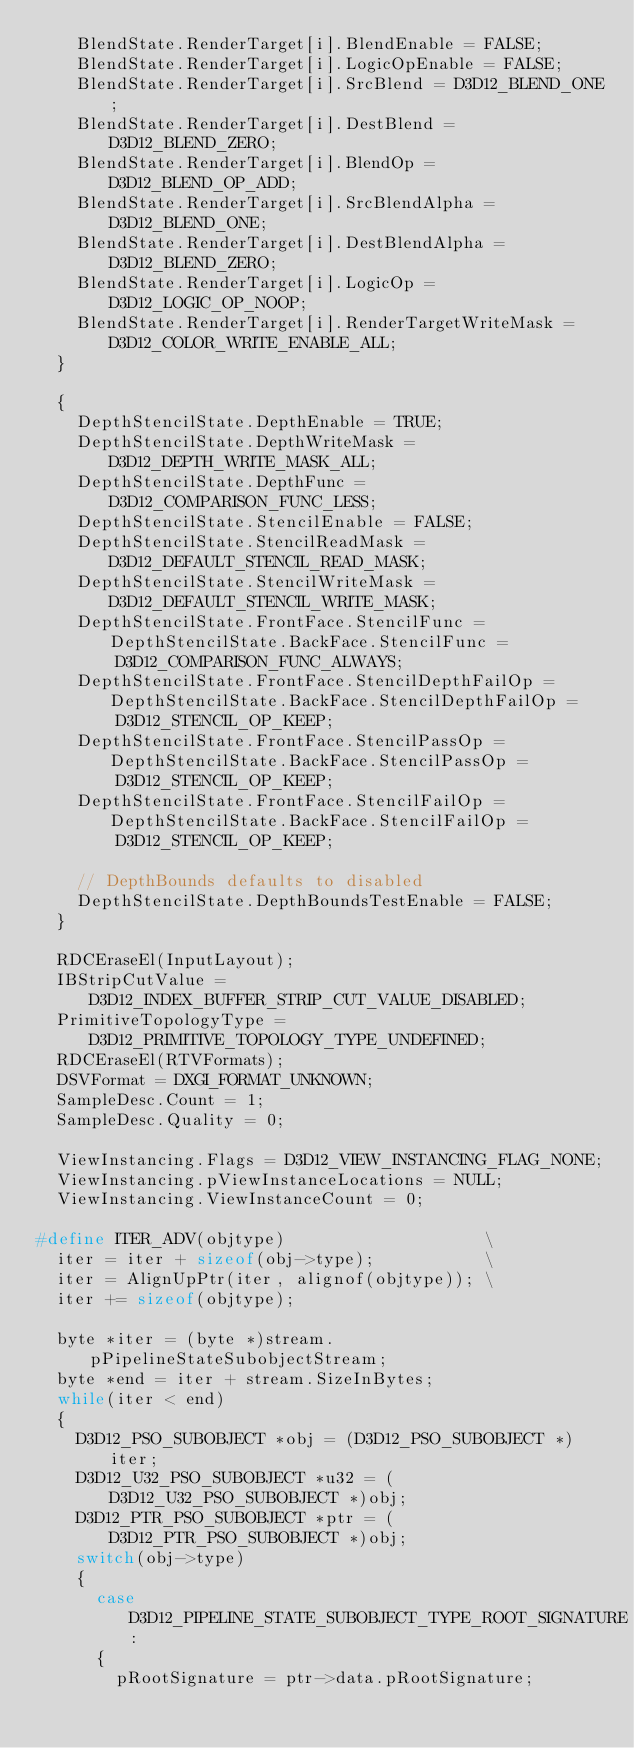<code> <loc_0><loc_0><loc_500><loc_500><_C++_>    BlendState.RenderTarget[i].BlendEnable = FALSE;
    BlendState.RenderTarget[i].LogicOpEnable = FALSE;
    BlendState.RenderTarget[i].SrcBlend = D3D12_BLEND_ONE;
    BlendState.RenderTarget[i].DestBlend = D3D12_BLEND_ZERO;
    BlendState.RenderTarget[i].BlendOp = D3D12_BLEND_OP_ADD;
    BlendState.RenderTarget[i].SrcBlendAlpha = D3D12_BLEND_ONE;
    BlendState.RenderTarget[i].DestBlendAlpha = D3D12_BLEND_ZERO;
    BlendState.RenderTarget[i].LogicOp = D3D12_LOGIC_OP_NOOP;
    BlendState.RenderTarget[i].RenderTargetWriteMask = D3D12_COLOR_WRITE_ENABLE_ALL;
  }

  {
    DepthStencilState.DepthEnable = TRUE;
    DepthStencilState.DepthWriteMask = D3D12_DEPTH_WRITE_MASK_ALL;
    DepthStencilState.DepthFunc = D3D12_COMPARISON_FUNC_LESS;
    DepthStencilState.StencilEnable = FALSE;
    DepthStencilState.StencilReadMask = D3D12_DEFAULT_STENCIL_READ_MASK;
    DepthStencilState.StencilWriteMask = D3D12_DEFAULT_STENCIL_WRITE_MASK;
    DepthStencilState.FrontFace.StencilFunc = DepthStencilState.BackFace.StencilFunc =
        D3D12_COMPARISON_FUNC_ALWAYS;
    DepthStencilState.FrontFace.StencilDepthFailOp = DepthStencilState.BackFace.StencilDepthFailOp =
        D3D12_STENCIL_OP_KEEP;
    DepthStencilState.FrontFace.StencilPassOp = DepthStencilState.BackFace.StencilPassOp =
        D3D12_STENCIL_OP_KEEP;
    DepthStencilState.FrontFace.StencilFailOp = DepthStencilState.BackFace.StencilFailOp =
        D3D12_STENCIL_OP_KEEP;

    // DepthBounds defaults to disabled
    DepthStencilState.DepthBoundsTestEnable = FALSE;
  }

  RDCEraseEl(InputLayout);
  IBStripCutValue = D3D12_INDEX_BUFFER_STRIP_CUT_VALUE_DISABLED;
  PrimitiveTopologyType = D3D12_PRIMITIVE_TOPOLOGY_TYPE_UNDEFINED;
  RDCEraseEl(RTVFormats);
  DSVFormat = DXGI_FORMAT_UNKNOWN;
  SampleDesc.Count = 1;
  SampleDesc.Quality = 0;

  ViewInstancing.Flags = D3D12_VIEW_INSTANCING_FLAG_NONE;
  ViewInstancing.pViewInstanceLocations = NULL;
  ViewInstancing.ViewInstanceCount = 0;

#define ITER_ADV(objtype)                    \
  iter = iter + sizeof(obj->type);           \
  iter = AlignUpPtr(iter, alignof(objtype)); \
  iter += sizeof(objtype);

  byte *iter = (byte *)stream.pPipelineStateSubobjectStream;
  byte *end = iter + stream.SizeInBytes;
  while(iter < end)
  {
    D3D12_PSO_SUBOBJECT *obj = (D3D12_PSO_SUBOBJECT *)iter;
    D3D12_U32_PSO_SUBOBJECT *u32 = (D3D12_U32_PSO_SUBOBJECT *)obj;
    D3D12_PTR_PSO_SUBOBJECT *ptr = (D3D12_PTR_PSO_SUBOBJECT *)obj;
    switch(obj->type)
    {
      case D3D12_PIPELINE_STATE_SUBOBJECT_TYPE_ROOT_SIGNATURE:
      {
        pRootSignature = ptr->data.pRootSignature;</code> 